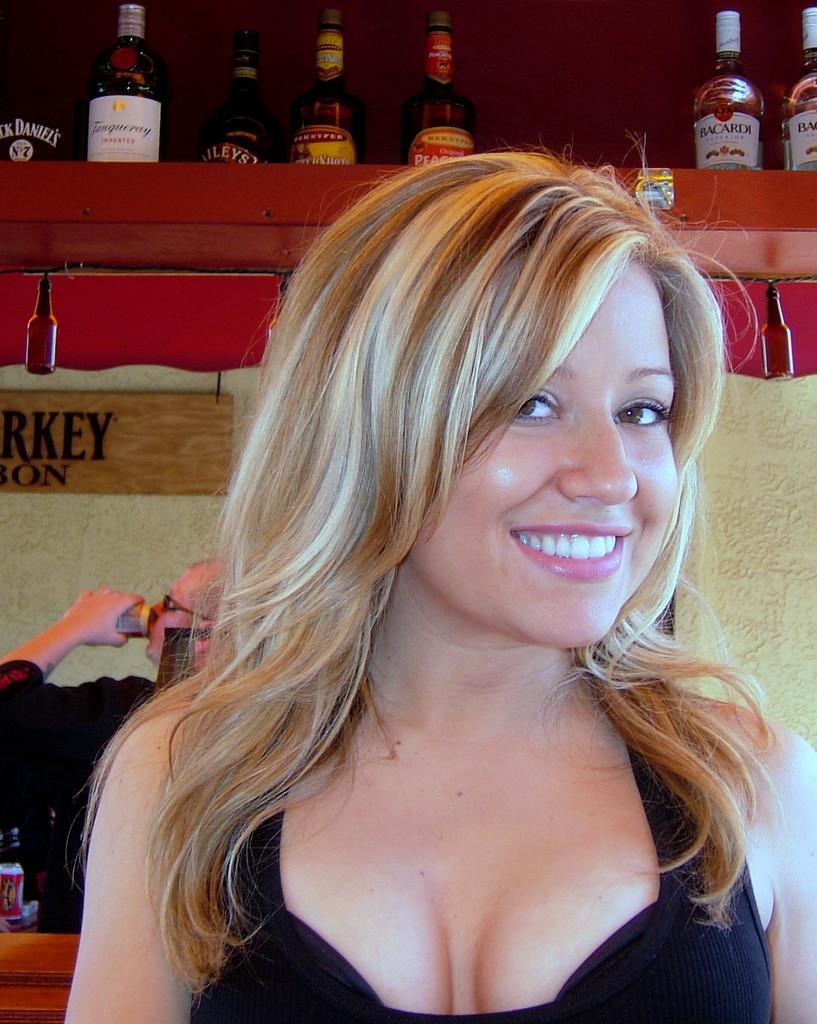Could you give a brief overview of what you see in this image? This image consists of a woman and on the top there are alcohol bottles and she is sitting on a chair. Behind her there is a photo of a person. This woman is wearing black color dress. She is smiling. 